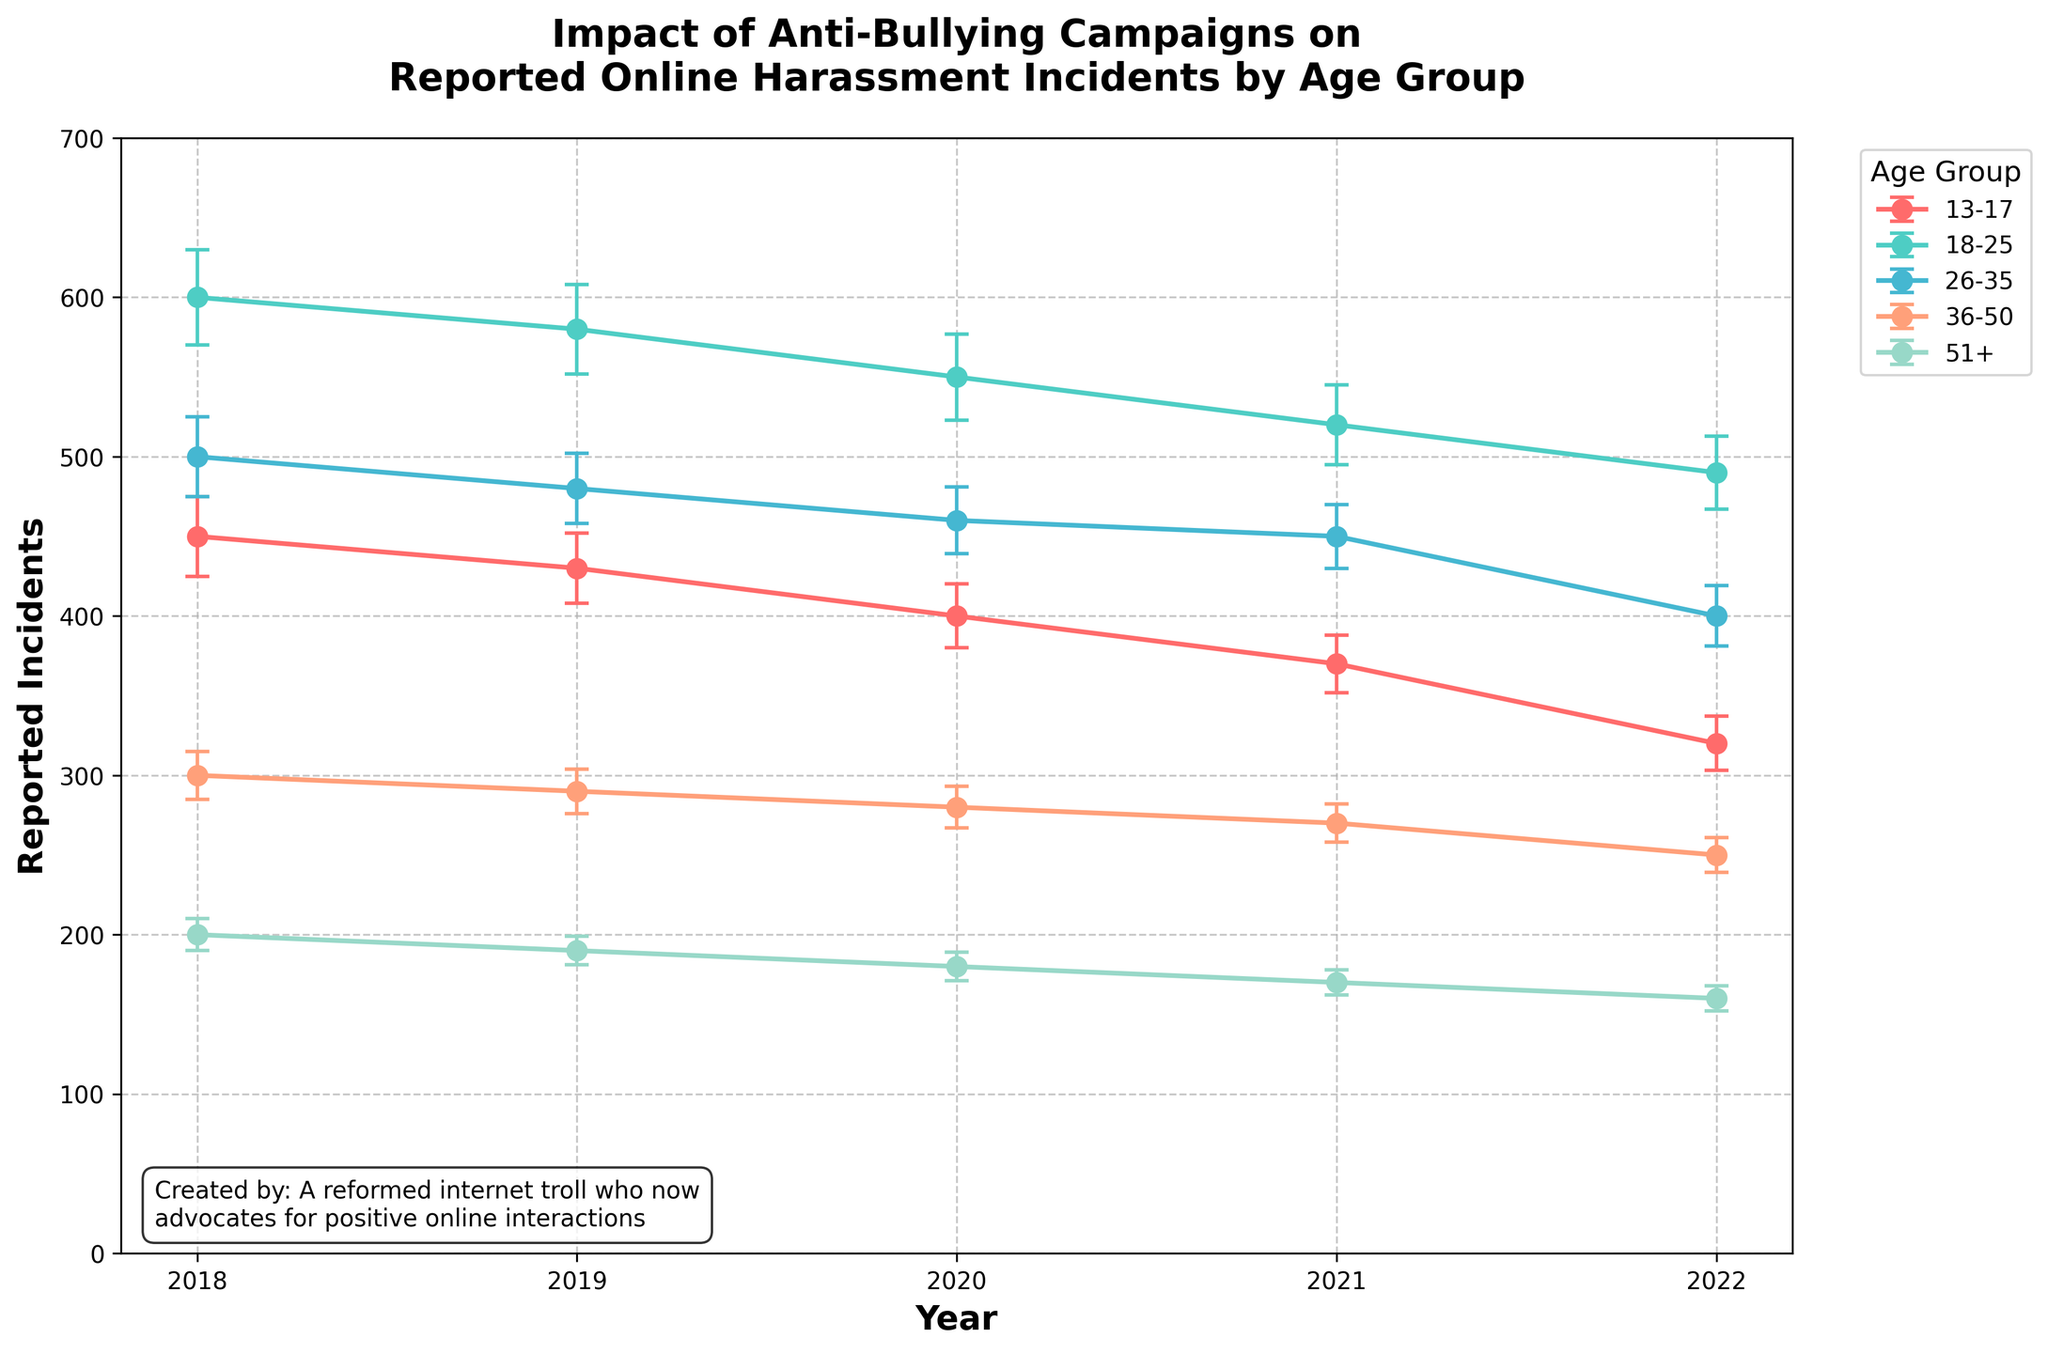What is the title of the plot? You can see the title at the top of the plot, which is "Impact of Anti-Bullying Campaigns on\nReported Online Harassment Incidents by Age Group".
Answer: Impact of Anti-Bullying Campaigns on Reported Online Harassment Incidents by Age Group How many age groups are represented in the plot? There are five lines with different colors representing five age groups: 13-17, 18-25, 26-35, 36-50, and 51+.
Answer: 5 What was the trend in reported incidents for the age group 13-17 from 2018 to 2022? The line for the 13-17 age group starts at 450 reported incidents in 2018 and decreases each year, reaching 320 incidents in 2022.
Answer: Decreasing Which age group had the highest number of reported incidents in 2022? The plot shows that in 2022, the age group 18-25 had the highest number of reported incidents at 490.
Answer: 18-25 What is the average number of reported incidents for the age group 26-35 across all years in the plot? Sum the reported incidents for 26-35 from 2018 to 2022 (500 + 480 + 460 + 450 + 400) = 2290, then divide by 5.
Answer: 458 Between which two consecutive years did the age group 36-50 see the smallest decrease in reported incidents? Look at the plot lines for the 36-50 group and compare decreases year by year: 2018-2019 is 10, 2019-2020 is 10, 2020-2021 is 10, 2021-2022 is 20.
Answer: 2018-2019, 2019-2020, 2020-2021 How does the error bar for the age group 13-17 in 2018 compare to that in 2022? The error bar for 13-17 in 2018 is larger than that in 2022, as indicated by the size of the bars.
Answer: Larger in 2018 In which year did the age group 51+ report the lowest number of incidents, and what was the value? The plot shows that in 2022, the age group 51+ reported the lowest number of incidents, which is 160.
Answer: 2022, 160 Calculate the total decrease in reported incidents for the age group 18-25 from 2018 to 2022. Subtract the value in 2022 from the value in 2018 for 18-25: 600 - 490 = 110.
Answer: 110 